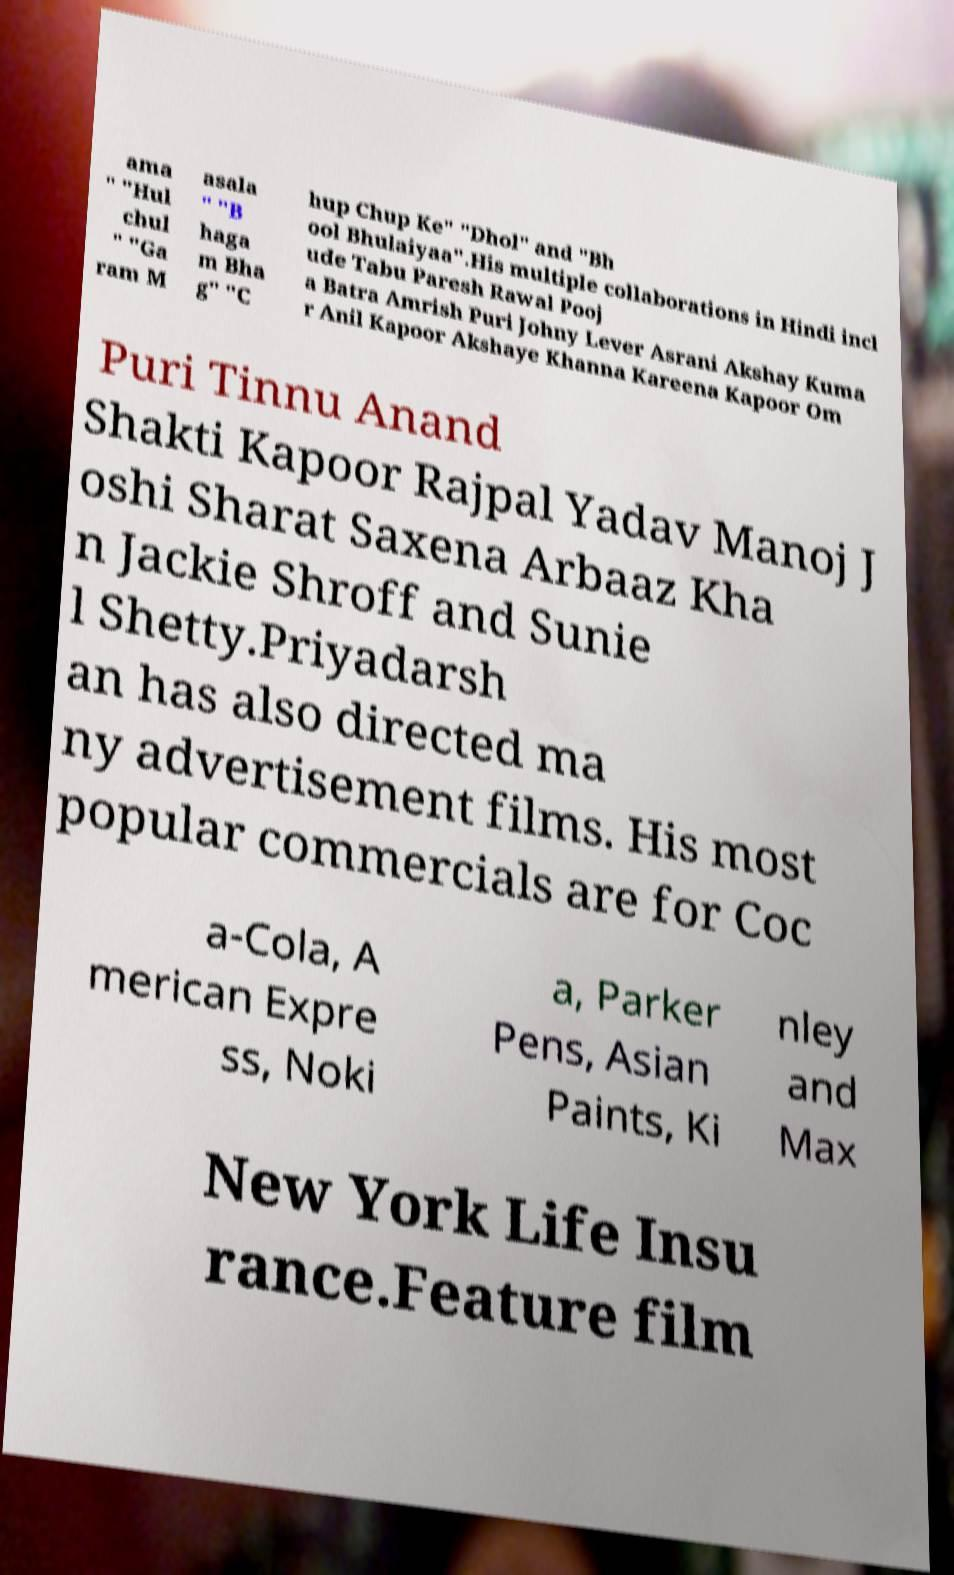Could you extract and type out the text from this image? ama " "Hul chul " "Ga ram M asala " "B haga m Bha g" "C hup Chup Ke" "Dhol" and "Bh ool Bhulaiyaa".His multiple collaborations in Hindi incl ude Tabu Paresh Rawal Pooj a Batra Amrish Puri Johny Lever Asrani Akshay Kuma r Anil Kapoor Akshaye Khanna Kareena Kapoor Om Puri Tinnu Anand Shakti Kapoor Rajpal Yadav Manoj J oshi Sharat Saxena Arbaaz Kha n Jackie Shroff and Sunie l Shetty.Priyadarsh an has also directed ma ny advertisement films. His most popular commercials are for Coc a-Cola, A merican Expre ss, Noki a, Parker Pens, Asian Paints, Ki nley and Max New York Life Insu rance.Feature film 